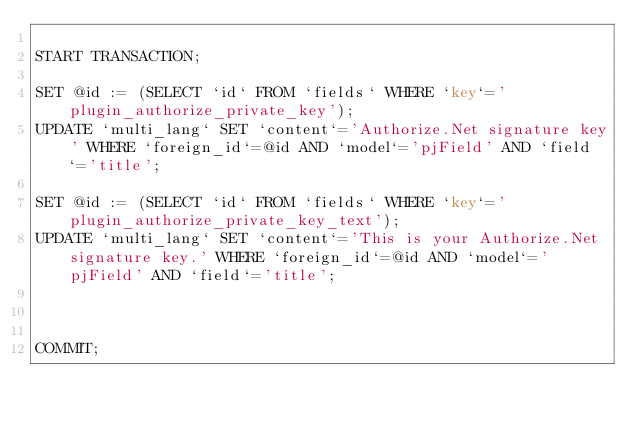Convert code to text. <code><loc_0><loc_0><loc_500><loc_500><_SQL_>
START TRANSACTION;

SET @id := (SELECT `id` FROM `fields` WHERE `key`='plugin_authorize_private_key');
UPDATE `multi_lang` SET `content`='Authorize.Net signature key' WHERE `foreign_id`=@id AND `model`='pjField' AND `field`='title';

SET @id := (SELECT `id` FROM `fields` WHERE `key`='plugin_authorize_private_key_text');
UPDATE `multi_lang` SET `content`='This is your Authorize.Net signature key.' WHERE `foreign_id`=@id AND `model`='pjField' AND `field`='title';



COMMIT;</code> 